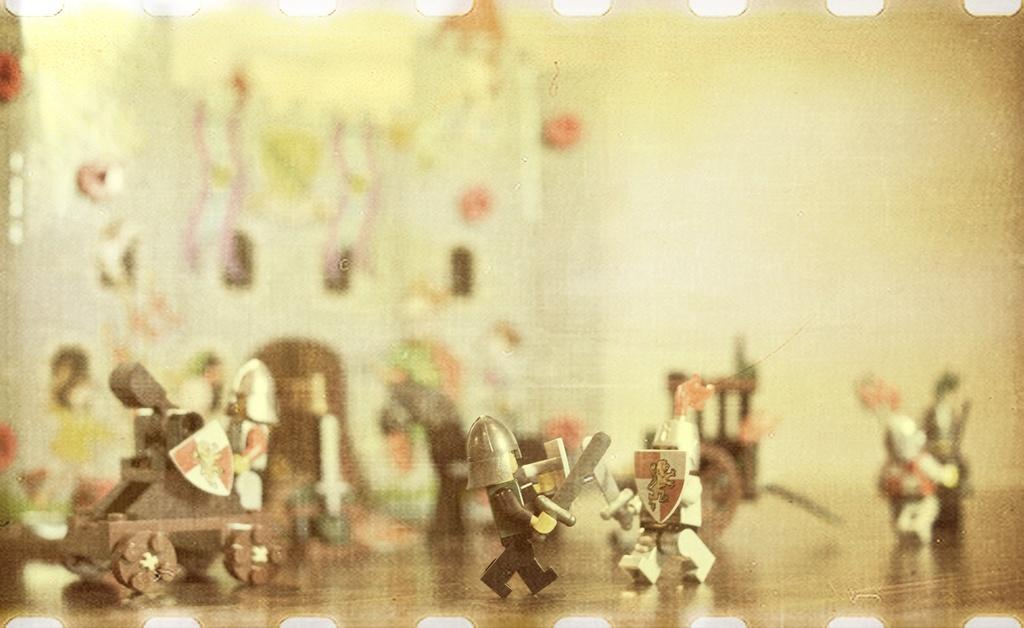What type of objects are in the image? There are miniature toys in the image. Where are the miniature toys located? The miniature toys are on a table. What type of pot is used to write the prose in the image? There is no pot or prose present in the image; it features miniature toys on a table. What type of brush is used to paint the prose in the image? There is no brush or prose present in the image; it features miniature toys on a table. 